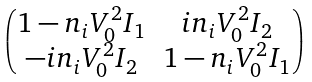<formula> <loc_0><loc_0><loc_500><loc_500>\begin{pmatrix} 1 - n _ { i } V _ { 0 } ^ { 2 } I _ { 1 } & i n _ { i } V _ { 0 } ^ { 2 } I _ { 2 } \\ - i n _ { i } V _ { 0 } ^ { 2 } I _ { 2 } & 1 - n _ { i } V _ { 0 } ^ { 2 } I _ { 1 } \end{pmatrix}</formula> 